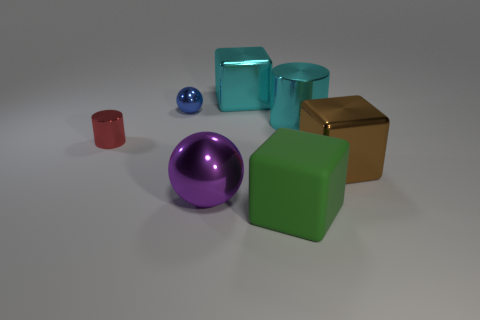Add 1 large brown things. How many objects exist? 8 Subtract all spheres. How many objects are left? 5 Subtract 1 purple balls. How many objects are left? 6 Subtract all big red matte objects. Subtract all metallic blocks. How many objects are left? 5 Add 1 big purple objects. How many big purple objects are left? 2 Add 6 purple objects. How many purple objects exist? 7 